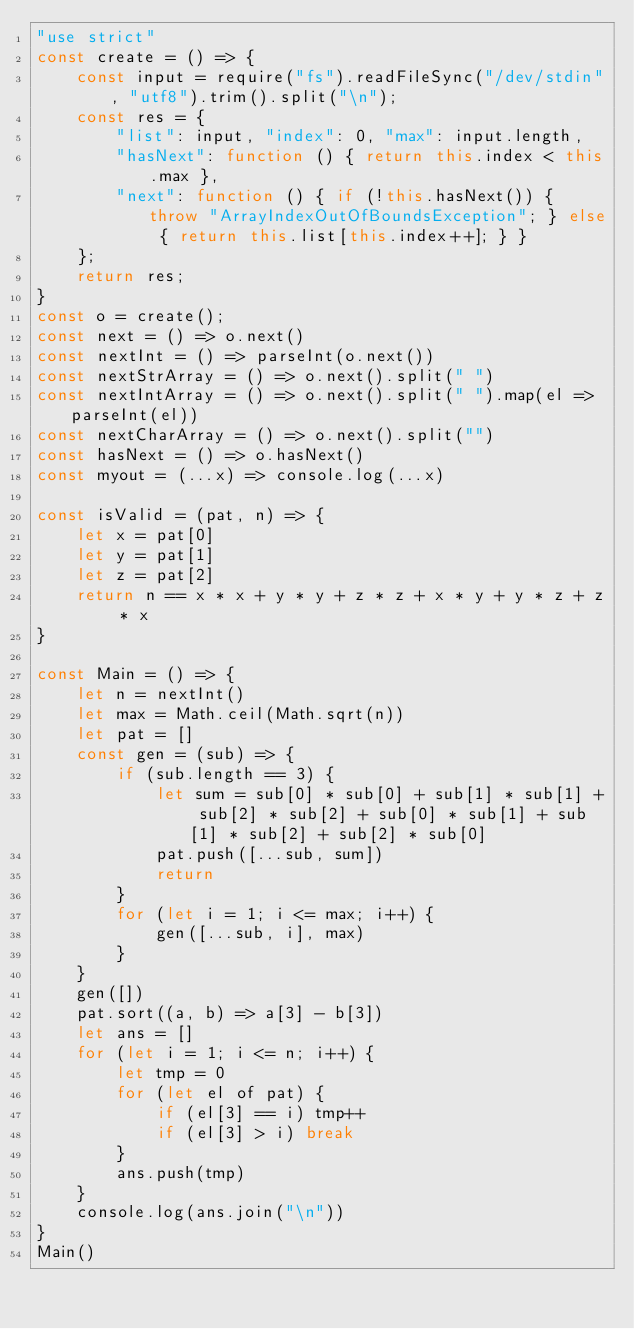<code> <loc_0><loc_0><loc_500><loc_500><_JavaScript_>"use strict"
const create = () => {
    const input = require("fs").readFileSync("/dev/stdin", "utf8").trim().split("\n");
    const res = {
        "list": input, "index": 0, "max": input.length,
        "hasNext": function () { return this.index < this.max },
        "next": function () { if (!this.hasNext()) { throw "ArrayIndexOutOfBoundsException"; } else { return this.list[this.index++]; } }
    };
    return res;
}
const o = create();
const next = () => o.next()
const nextInt = () => parseInt(o.next())
const nextStrArray = () => o.next().split(" ")
const nextIntArray = () => o.next().split(" ").map(el => parseInt(el))
const nextCharArray = () => o.next().split("")
const hasNext = () => o.hasNext()
const myout = (...x) => console.log(...x)

const isValid = (pat, n) => {
    let x = pat[0]
    let y = pat[1]
    let z = pat[2]
    return n == x * x + y * y + z * z + x * y + y * z + z * x
}

const Main = () => {
    let n = nextInt()
    let max = Math.ceil(Math.sqrt(n))
    let pat = []
    const gen = (sub) => {
        if (sub.length == 3) {
            let sum = sub[0] * sub[0] + sub[1] * sub[1] + sub[2] * sub[2] + sub[0] * sub[1] + sub[1] * sub[2] + sub[2] * sub[0]
            pat.push([...sub, sum])
            return
        }
        for (let i = 1; i <= max; i++) {
            gen([...sub, i], max)
        }
    }
    gen([])
    pat.sort((a, b) => a[3] - b[3])
    let ans = []
    for (let i = 1; i <= n; i++) {
        let tmp = 0
        for (let el of pat) {
            if (el[3] == i) tmp++
            if (el[3] > i) break
        }
        ans.push(tmp)
    }
    console.log(ans.join("\n"))
}
Main()

</code> 